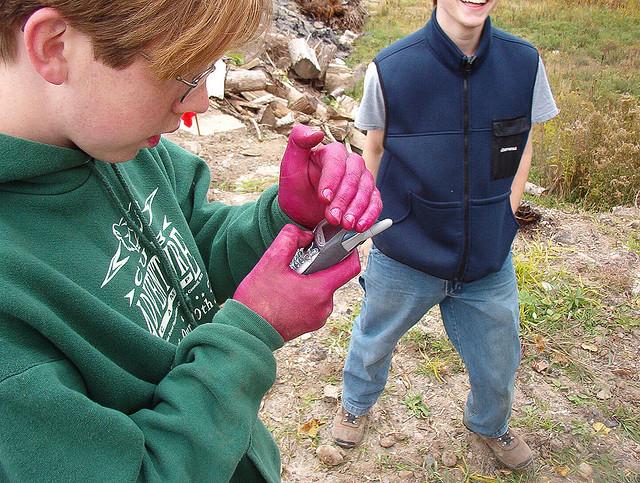Are they outside?
Quick response, please. Yes. Is the grass?
Short answer required. Yes. What color are the kids hands?
Concise answer only. Red. 